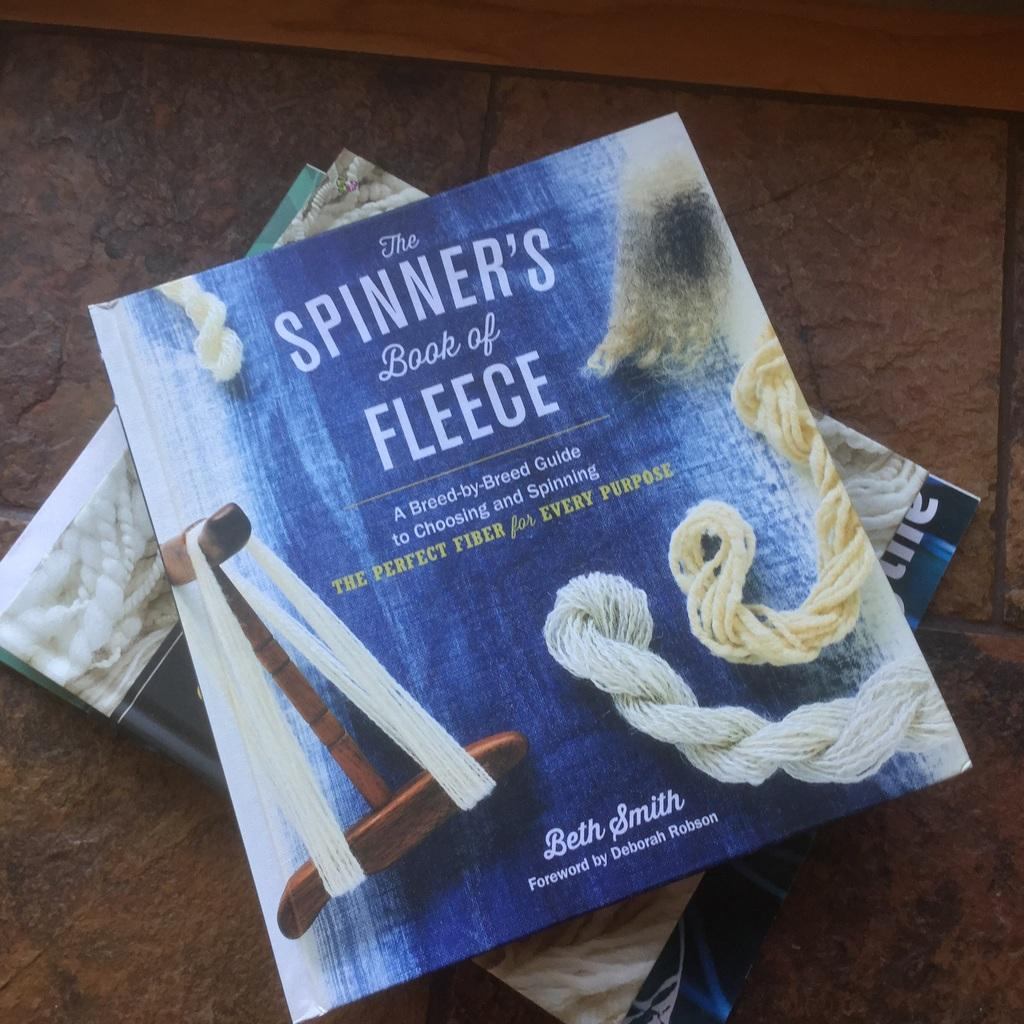Provide a one-sentence caption for the provided image. The spinners book of Fleece stacked upon other books. 